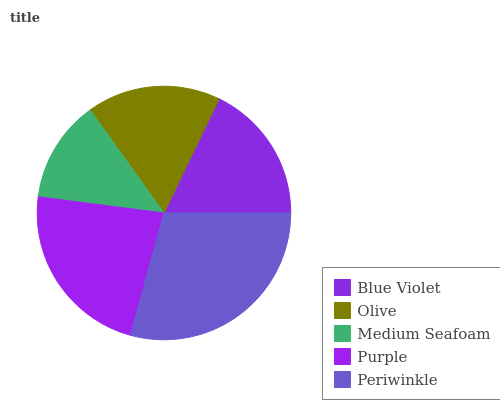Is Medium Seafoam the minimum?
Answer yes or no. Yes. Is Periwinkle the maximum?
Answer yes or no. Yes. Is Olive the minimum?
Answer yes or no. No. Is Olive the maximum?
Answer yes or no. No. Is Blue Violet greater than Olive?
Answer yes or no. Yes. Is Olive less than Blue Violet?
Answer yes or no. Yes. Is Olive greater than Blue Violet?
Answer yes or no. No. Is Blue Violet less than Olive?
Answer yes or no. No. Is Blue Violet the high median?
Answer yes or no. Yes. Is Blue Violet the low median?
Answer yes or no. Yes. Is Olive the high median?
Answer yes or no. No. Is Medium Seafoam the low median?
Answer yes or no. No. 